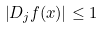Convert formula to latex. <formula><loc_0><loc_0><loc_500><loc_500>\left | D _ { j } f ( x ) \right | \leq 1 \quad</formula> 